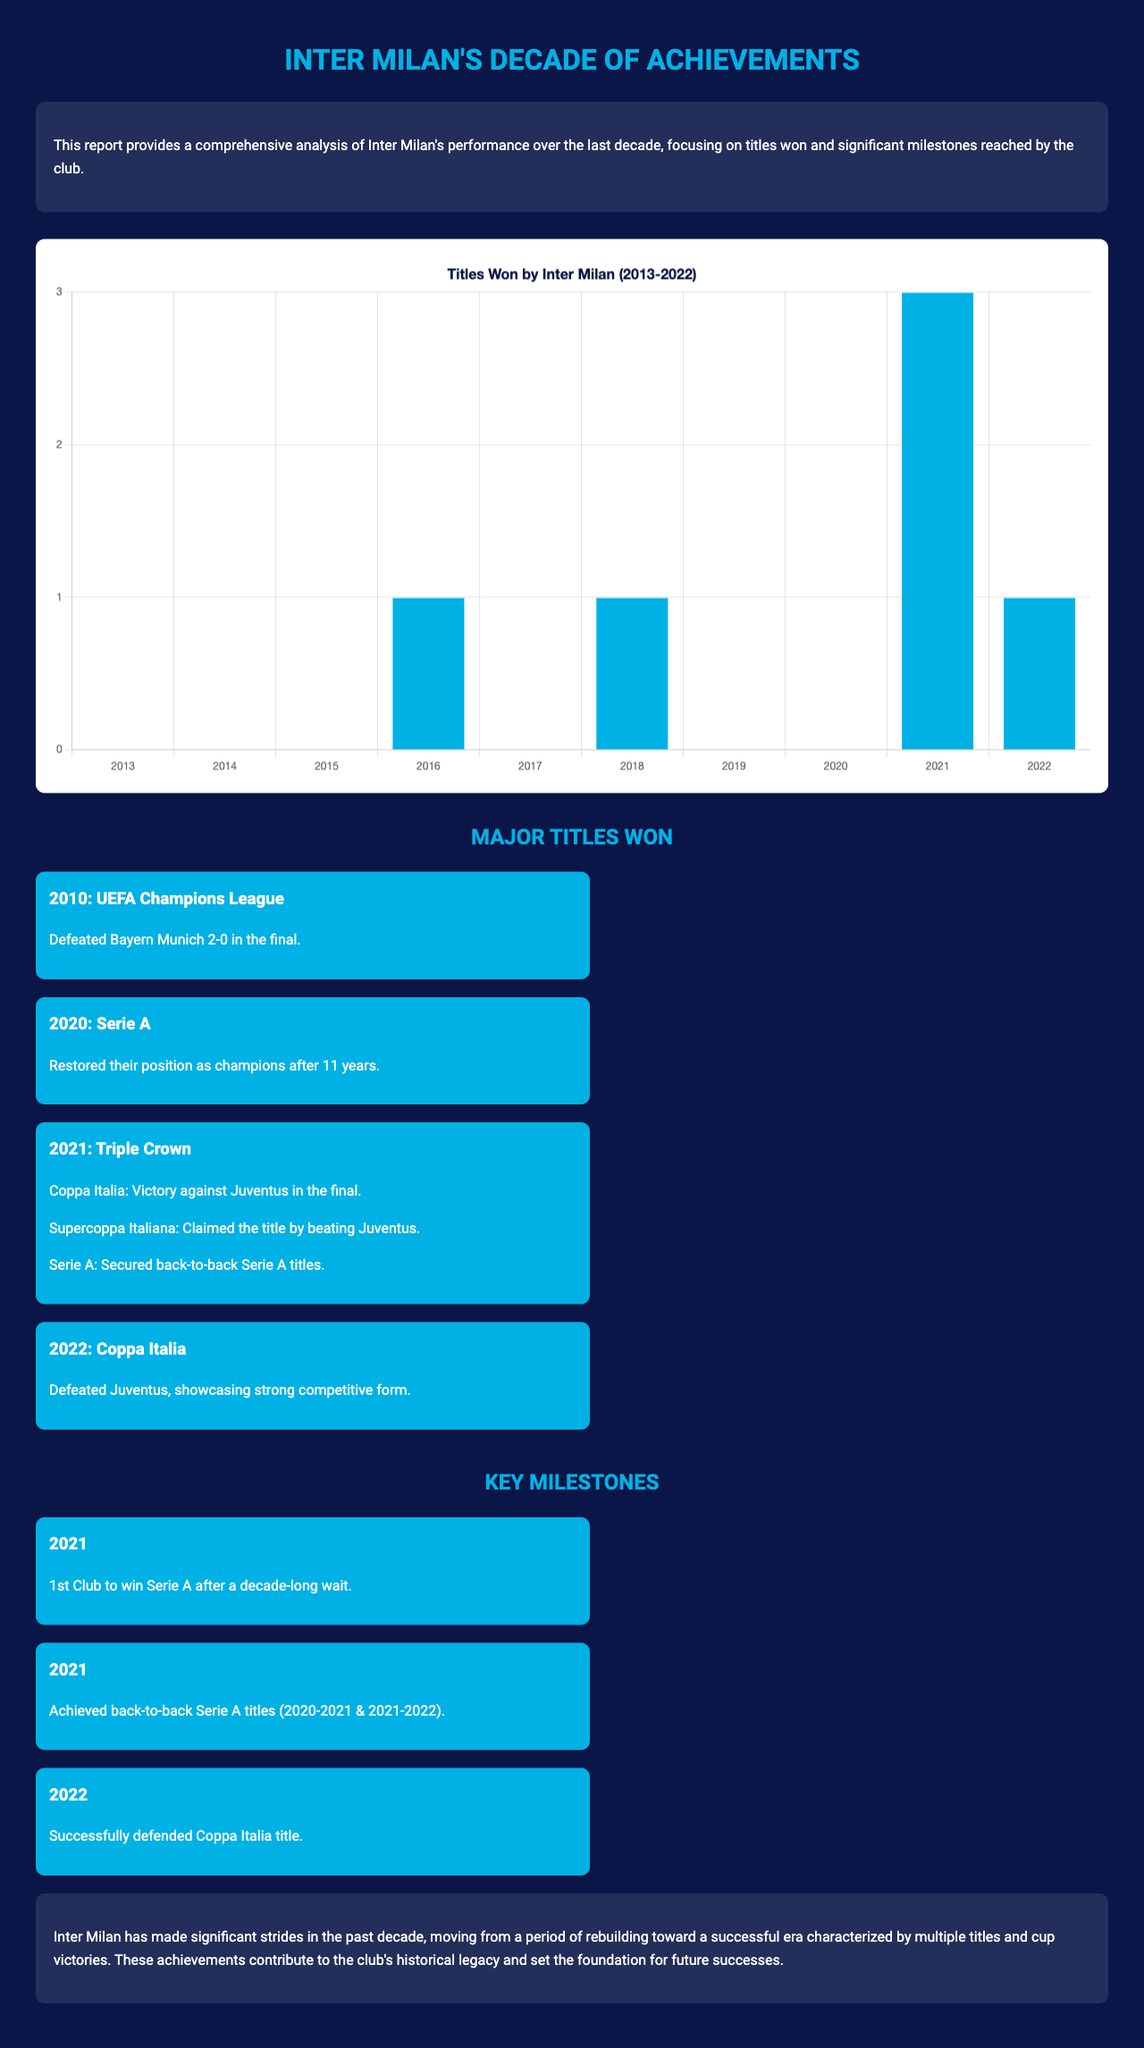What was the last title won by Inter Milan? The last title listed in the document is the Coppa Italia won in 2022.
Answer: Coppa Italia What significant achievement occurred in 2021? In 2021, Inter Milan became the 1st club to win Serie A after a decade-long wait.
Answer: 1st Club to win Serie A How many titles did Inter Milan win in 2021? The document mentions that Inter Milan secured three titles in 2021 (Serie A, Coppa Italia, and Supercoppa Italiana).
Answer: 3 In which year did Inter Milan last win the UEFA Champions League? The document states that Inter Milan won the UEFA Champions League in 2010.
Answer: 2010 How many total titles were won by Inter Milan from 2013 to 2022? By analyzing the chart, the total number of titles won from 2013 to 2022 is 6.
Answer: 6 What color represents the titles won in the chart? The color representing titles won in the chart is blue, specified as #00b1e5.
Answer: Blue What year did Inter Milan achieve back-to-back Serie A titles? The back-to-back Serie A titles were achieved in the years 2020 and 2021.
Answer: 2020 and 2021 Which notable rival did Inter Milan defeat in the Coppa Italia final in 2022? The document notes that Inter Milan defeated Juventus in the Coppa Italia final in 2022.
Answer: Juventus 